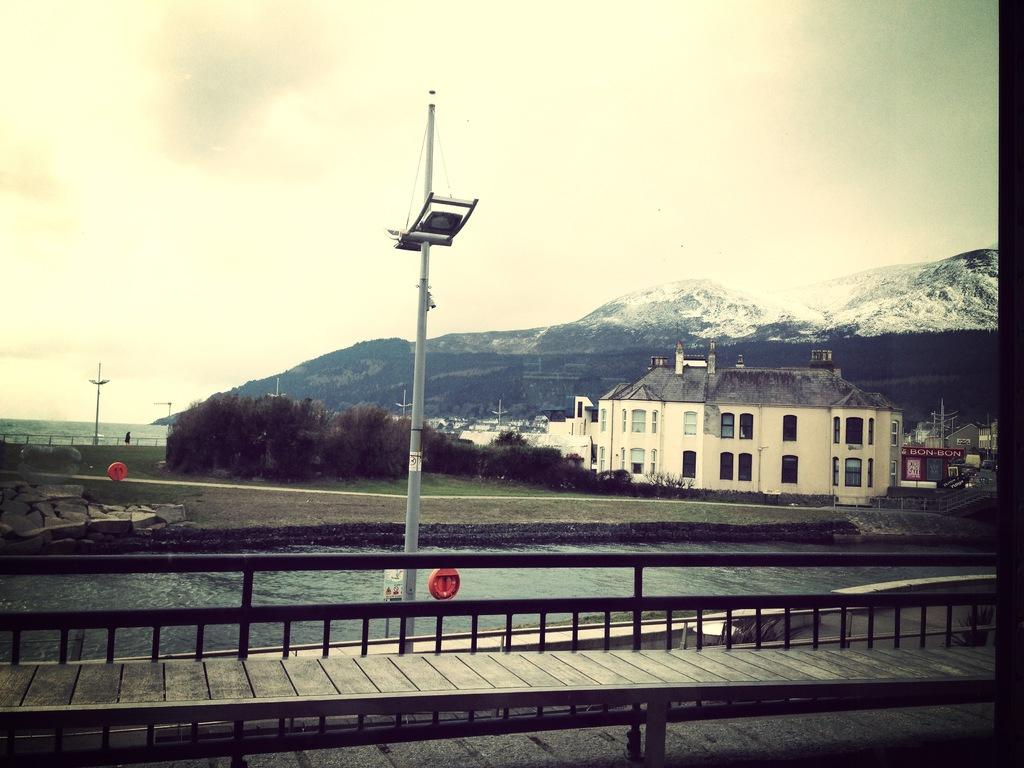What is located in the middle of the image? There is a canal in the middle of the image. What can be seen behind the canal? There are buildings behind the canal. What is located behind the buildings? There are trees behind the buildings. What is in the front of the canal? There is a bridge in the front of the canal. What can be seen in the background of the image? There are hills covered with snow in the background, and the sky is visible above the hills. What type of roof can be heard on the coast in the image? There is no mention of a roof or a coast in the image; it features a canal, buildings, trees, a bridge, hills, and the sky. 